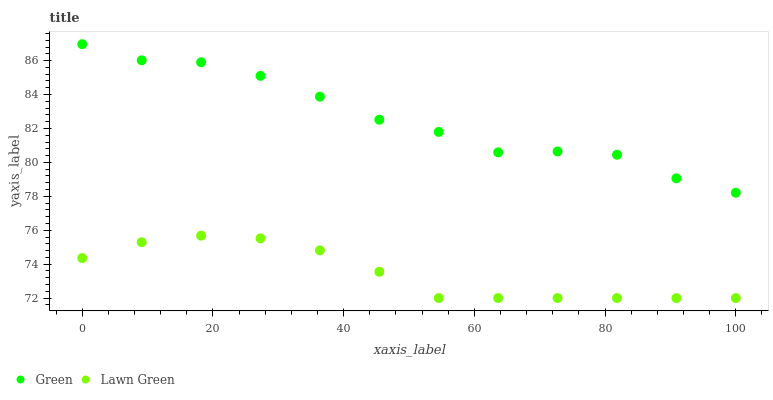Does Lawn Green have the minimum area under the curve?
Answer yes or no. Yes. Does Green have the maximum area under the curve?
Answer yes or no. Yes. Does Green have the minimum area under the curve?
Answer yes or no. No. Is Lawn Green the smoothest?
Answer yes or no. Yes. Is Green the roughest?
Answer yes or no. Yes. Is Green the smoothest?
Answer yes or no. No. Does Lawn Green have the lowest value?
Answer yes or no. Yes. Does Green have the lowest value?
Answer yes or no. No. Does Green have the highest value?
Answer yes or no. Yes. Is Lawn Green less than Green?
Answer yes or no. Yes. Is Green greater than Lawn Green?
Answer yes or no. Yes. Does Lawn Green intersect Green?
Answer yes or no. No. 